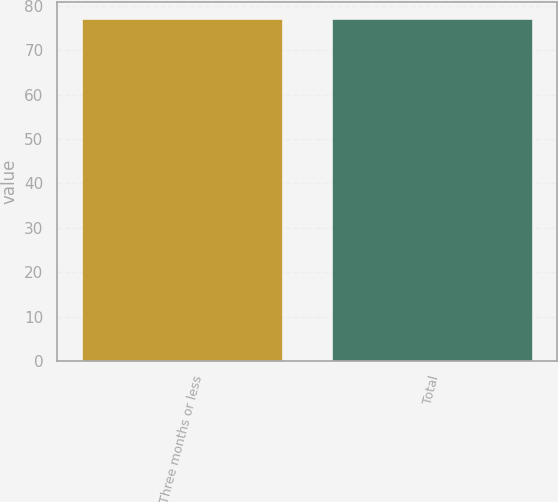Convert chart to OTSL. <chart><loc_0><loc_0><loc_500><loc_500><bar_chart><fcel>Three months or less<fcel>Total<nl><fcel>77<fcel>77.1<nl></chart> 